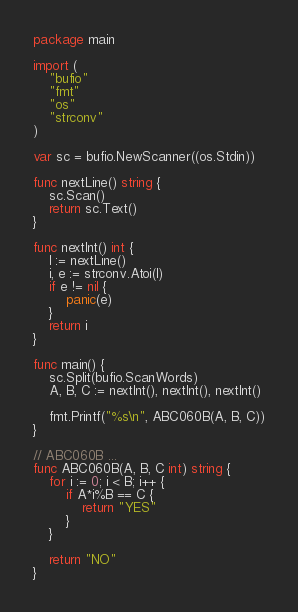<code> <loc_0><loc_0><loc_500><loc_500><_Go_>package main

import (
	"bufio"
	"fmt"
	"os"
	"strconv"
)

var sc = bufio.NewScanner((os.Stdin))

func nextLine() string {
	sc.Scan()
	return sc.Text()
}

func nextInt() int {
	l := nextLine()
	i, e := strconv.Atoi(l)
	if e != nil {
		panic(e)
	}
	return i
}

func main() {
	sc.Split(bufio.ScanWords)
	A, B, C := nextInt(), nextInt(), nextInt()

	fmt.Printf("%s\n", ABC060B(A, B, C))
}

// ABC060B ...
func ABC060B(A, B, C int) string {
	for i := 0; i < B; i++ {
		if A*i%B == C {
			return "YES"
		}
	}

	return "NO"
}
</code> 